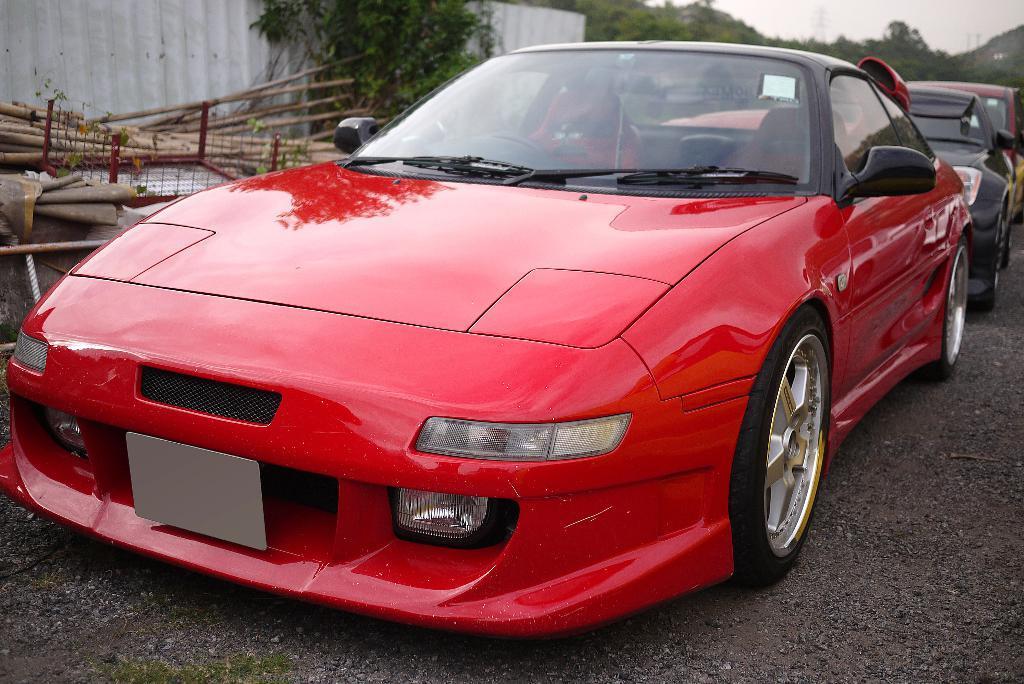How would you summarize this image in a sentence or two? In the center of the image we can see vehicles on the road. In the background we can see hills, trees, wooden sticks and sky. 